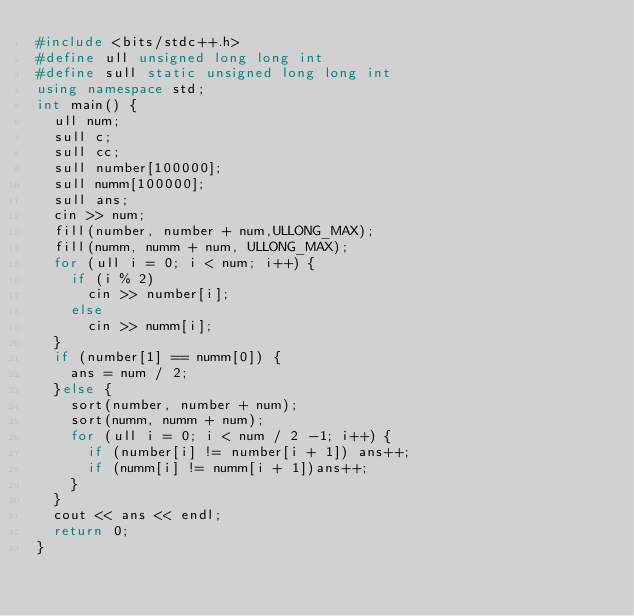Convert code to text. <code><loc_0><loc_0><loc_500><loc_500><_C++_>#include <bits/stdc++.h>
#define ull unsigned long long int 
#define sull static unsigned long long int
using namespace std;
int main() {
	ull num;
	sull c;
	sull cc;
	sull number[100000];
	sull numm[100000];
	sull ans;
	cin >> num;
	fill(number, number + num,ULLONG_MAX);
	fill(numm, numm + num, ULLONG_MAX);
	for (ull i = 0; i < num; i++) {
		if (i % 2)
			cin >> number[i];
		else
			cin >> numm[i];
	}
	if (number[1] == numm[0]) {
		ans = num / 2;
	}else {
		sort(number, number + num);
		sort(numm, numm + num);
		for (ull i = 0; i < num / 2 -1; i++) {
			if (number[i] != number[i + 1]) ans++;
			if (numm[i] != numm[i + 1])ans++;
		}
	}
	cout << ans << endl;
	return 0;
}</code> 